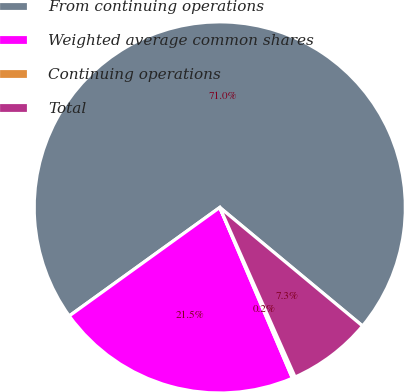<chart> <loc_0><loc_0><loc_500><loc_500><pie_chart><fcel>From continuing operations<fcel>Weighted average common shares<fcel>Continuing operations<fcel>Total<nl><fcel>70.97%<fcel>21.46%<fcel>0.25%<fcel>7.32%<nl></chart> 